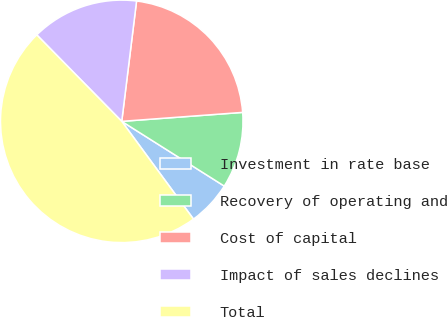Convert chart. <chart><loc_0><loc_0><loc_500><loc_500><pie_chart><fcel>Investment in rate base<fcel>Recovery of operating and<fcel>Cost of capital<fcel>Impact of sales declines<fcel>Total<nl><fcel>5.96%<fcel>10.14%<fcel>21.87%<fcel>14.31%<fcel>47.71%<nl></chart> 